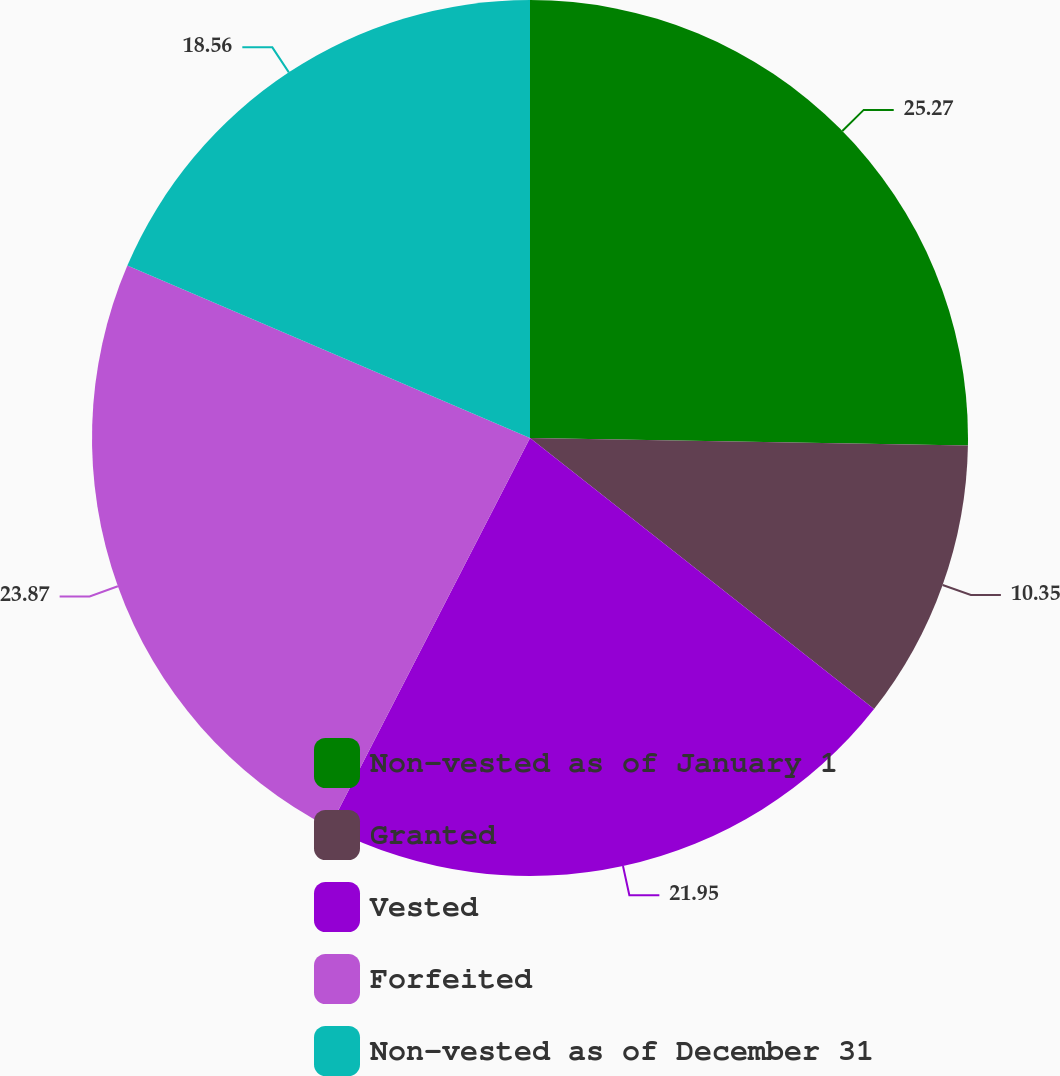Convert chart. <chart><loc_0><loc_0><loc_500><loc_500><pie_chart><fcel>Non-vested as of January 1<fcel>Granted<fcel>Vested<fcel>Forfeited<fcel>Non-vested as of December 31<nl><fcel>25.27%<fcel>10.35%<fcel>21.95%<fcel>23.87%<fcel>18.56%<nl></chart> 